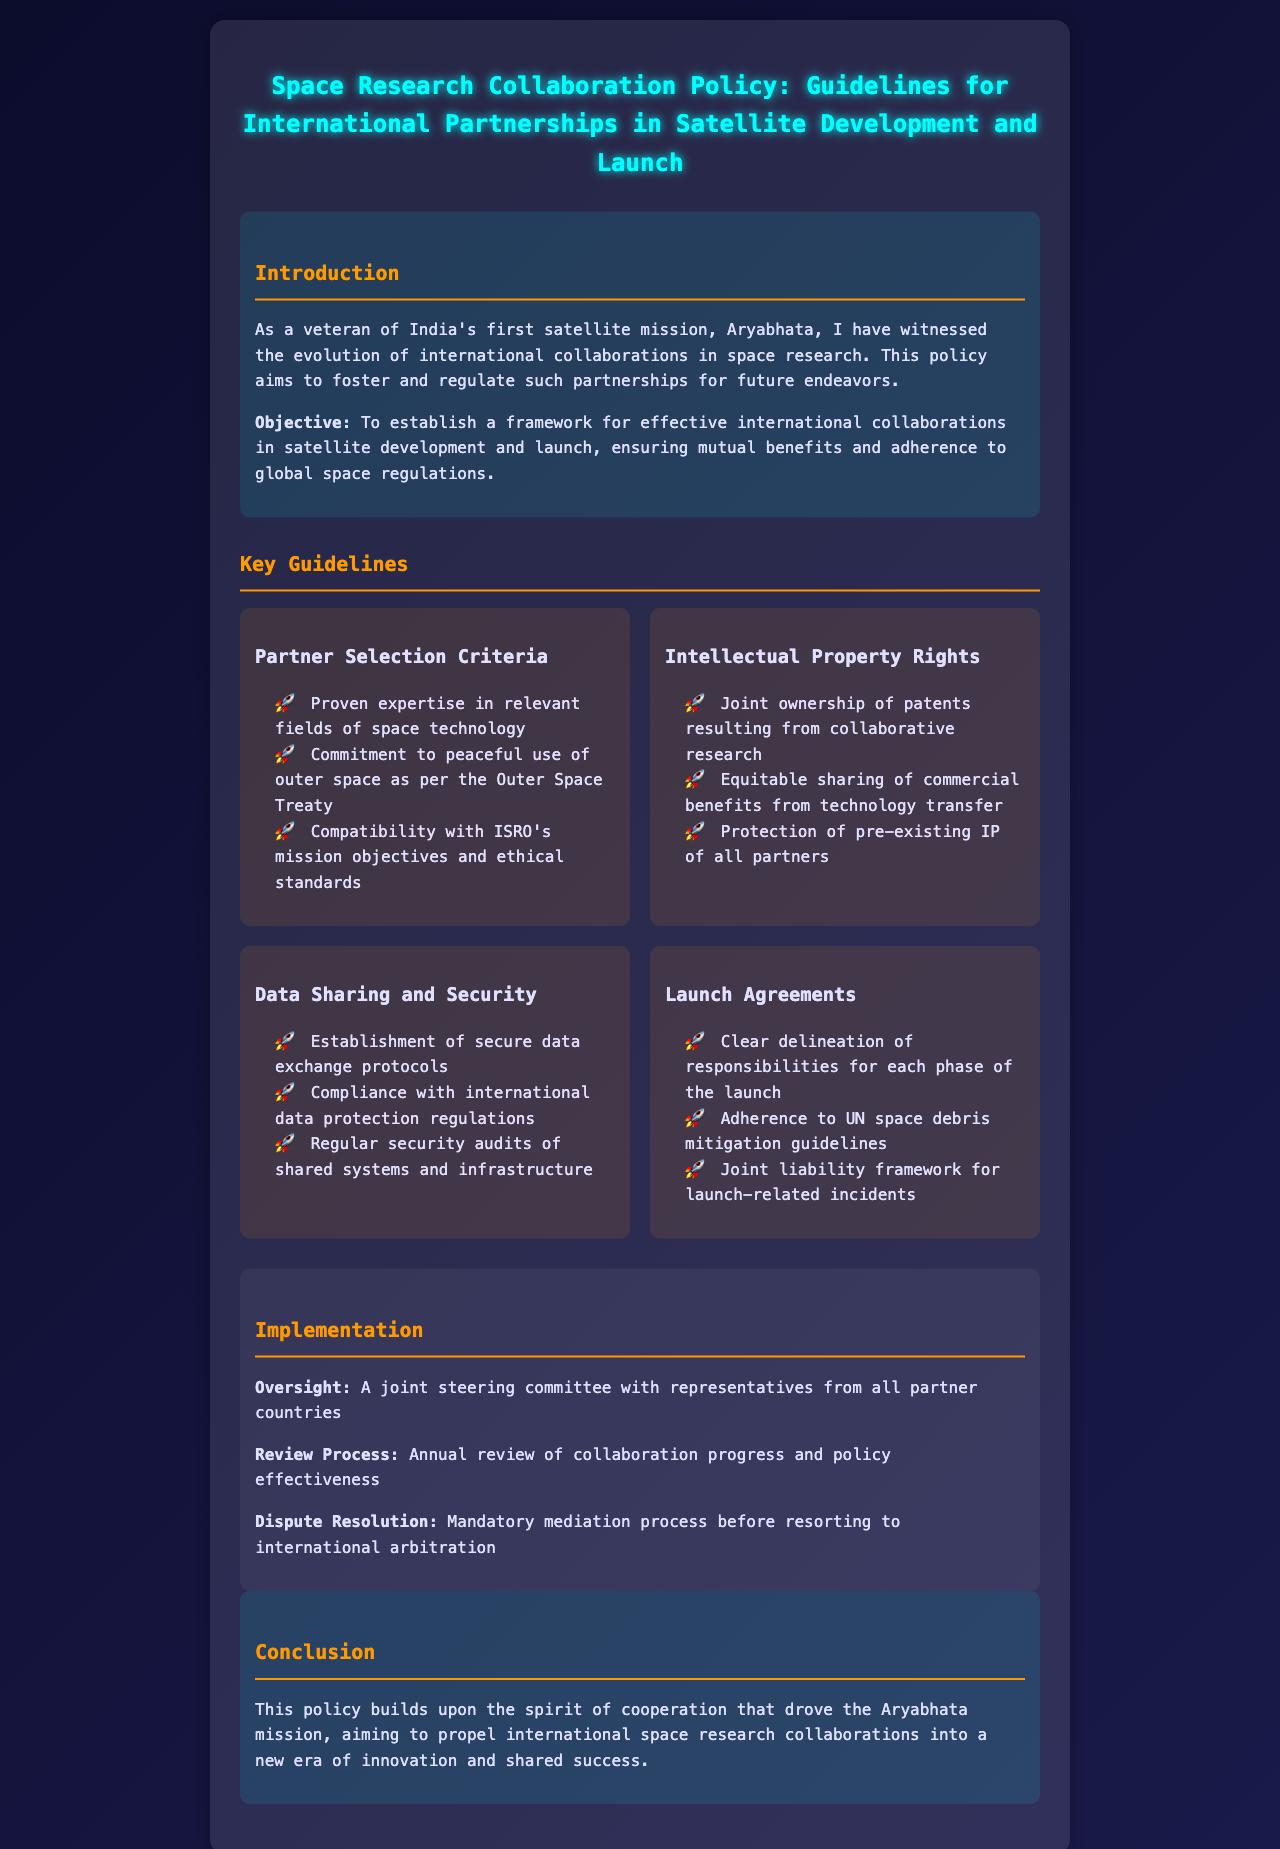What is the title of the policy document? The title is stated at the top of the document.
Answer: Space Research Collaboration Policy: Guidelines for International Partnerships in Satellite Development and Launch What is the objective of the policy? The objective is highlighted in the introduction section.
Answer: To establish a framework for effective international collaborations in satellite development and launch, ensuring mutual benefits and adherence to global space regulations Who are the key participants in oversight? The oversight section mentions who participates.
Answer: A joint steering committee with representatives from all partner countries What is the guideline regarding data sharing? The data sharing guideline specifies one of the main protocols.
Answer: Establishment of secure data exchange protocols What does the conclusion highlight? The conclusion summarizes the intention behind the policy.
Answer: This policy builds upon the spirit of cooperation that drove the Aryabhata mission What type of IP arrangement is mentioned? The second bullet under Intellectual Property Rights outlines this arrangement.
Answer: Joint ownership of patents resulting from collaborative research What must be adhered to according to the Launch Agreements? The Launch Agreements mention an important guideline related to space.
Answer: Adherence to UN space debris mitigation guidelines How often is the review process conducted? The review process mentions its frequency in the document.
Answer: Annual review What is the required process before international arbitration? The dispute resolution section details this requirement.
Answer: Mandatory mediation process before resorting to international arbitration 